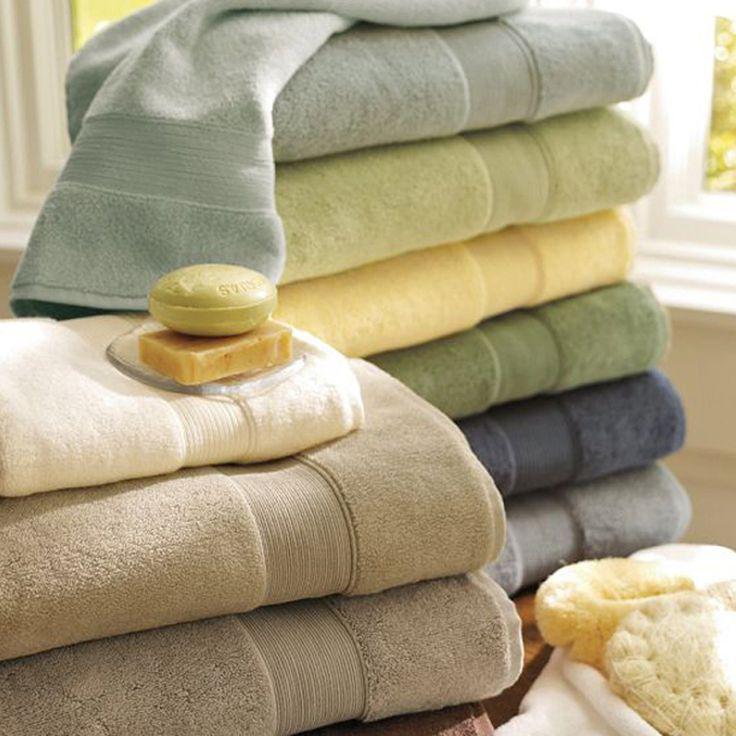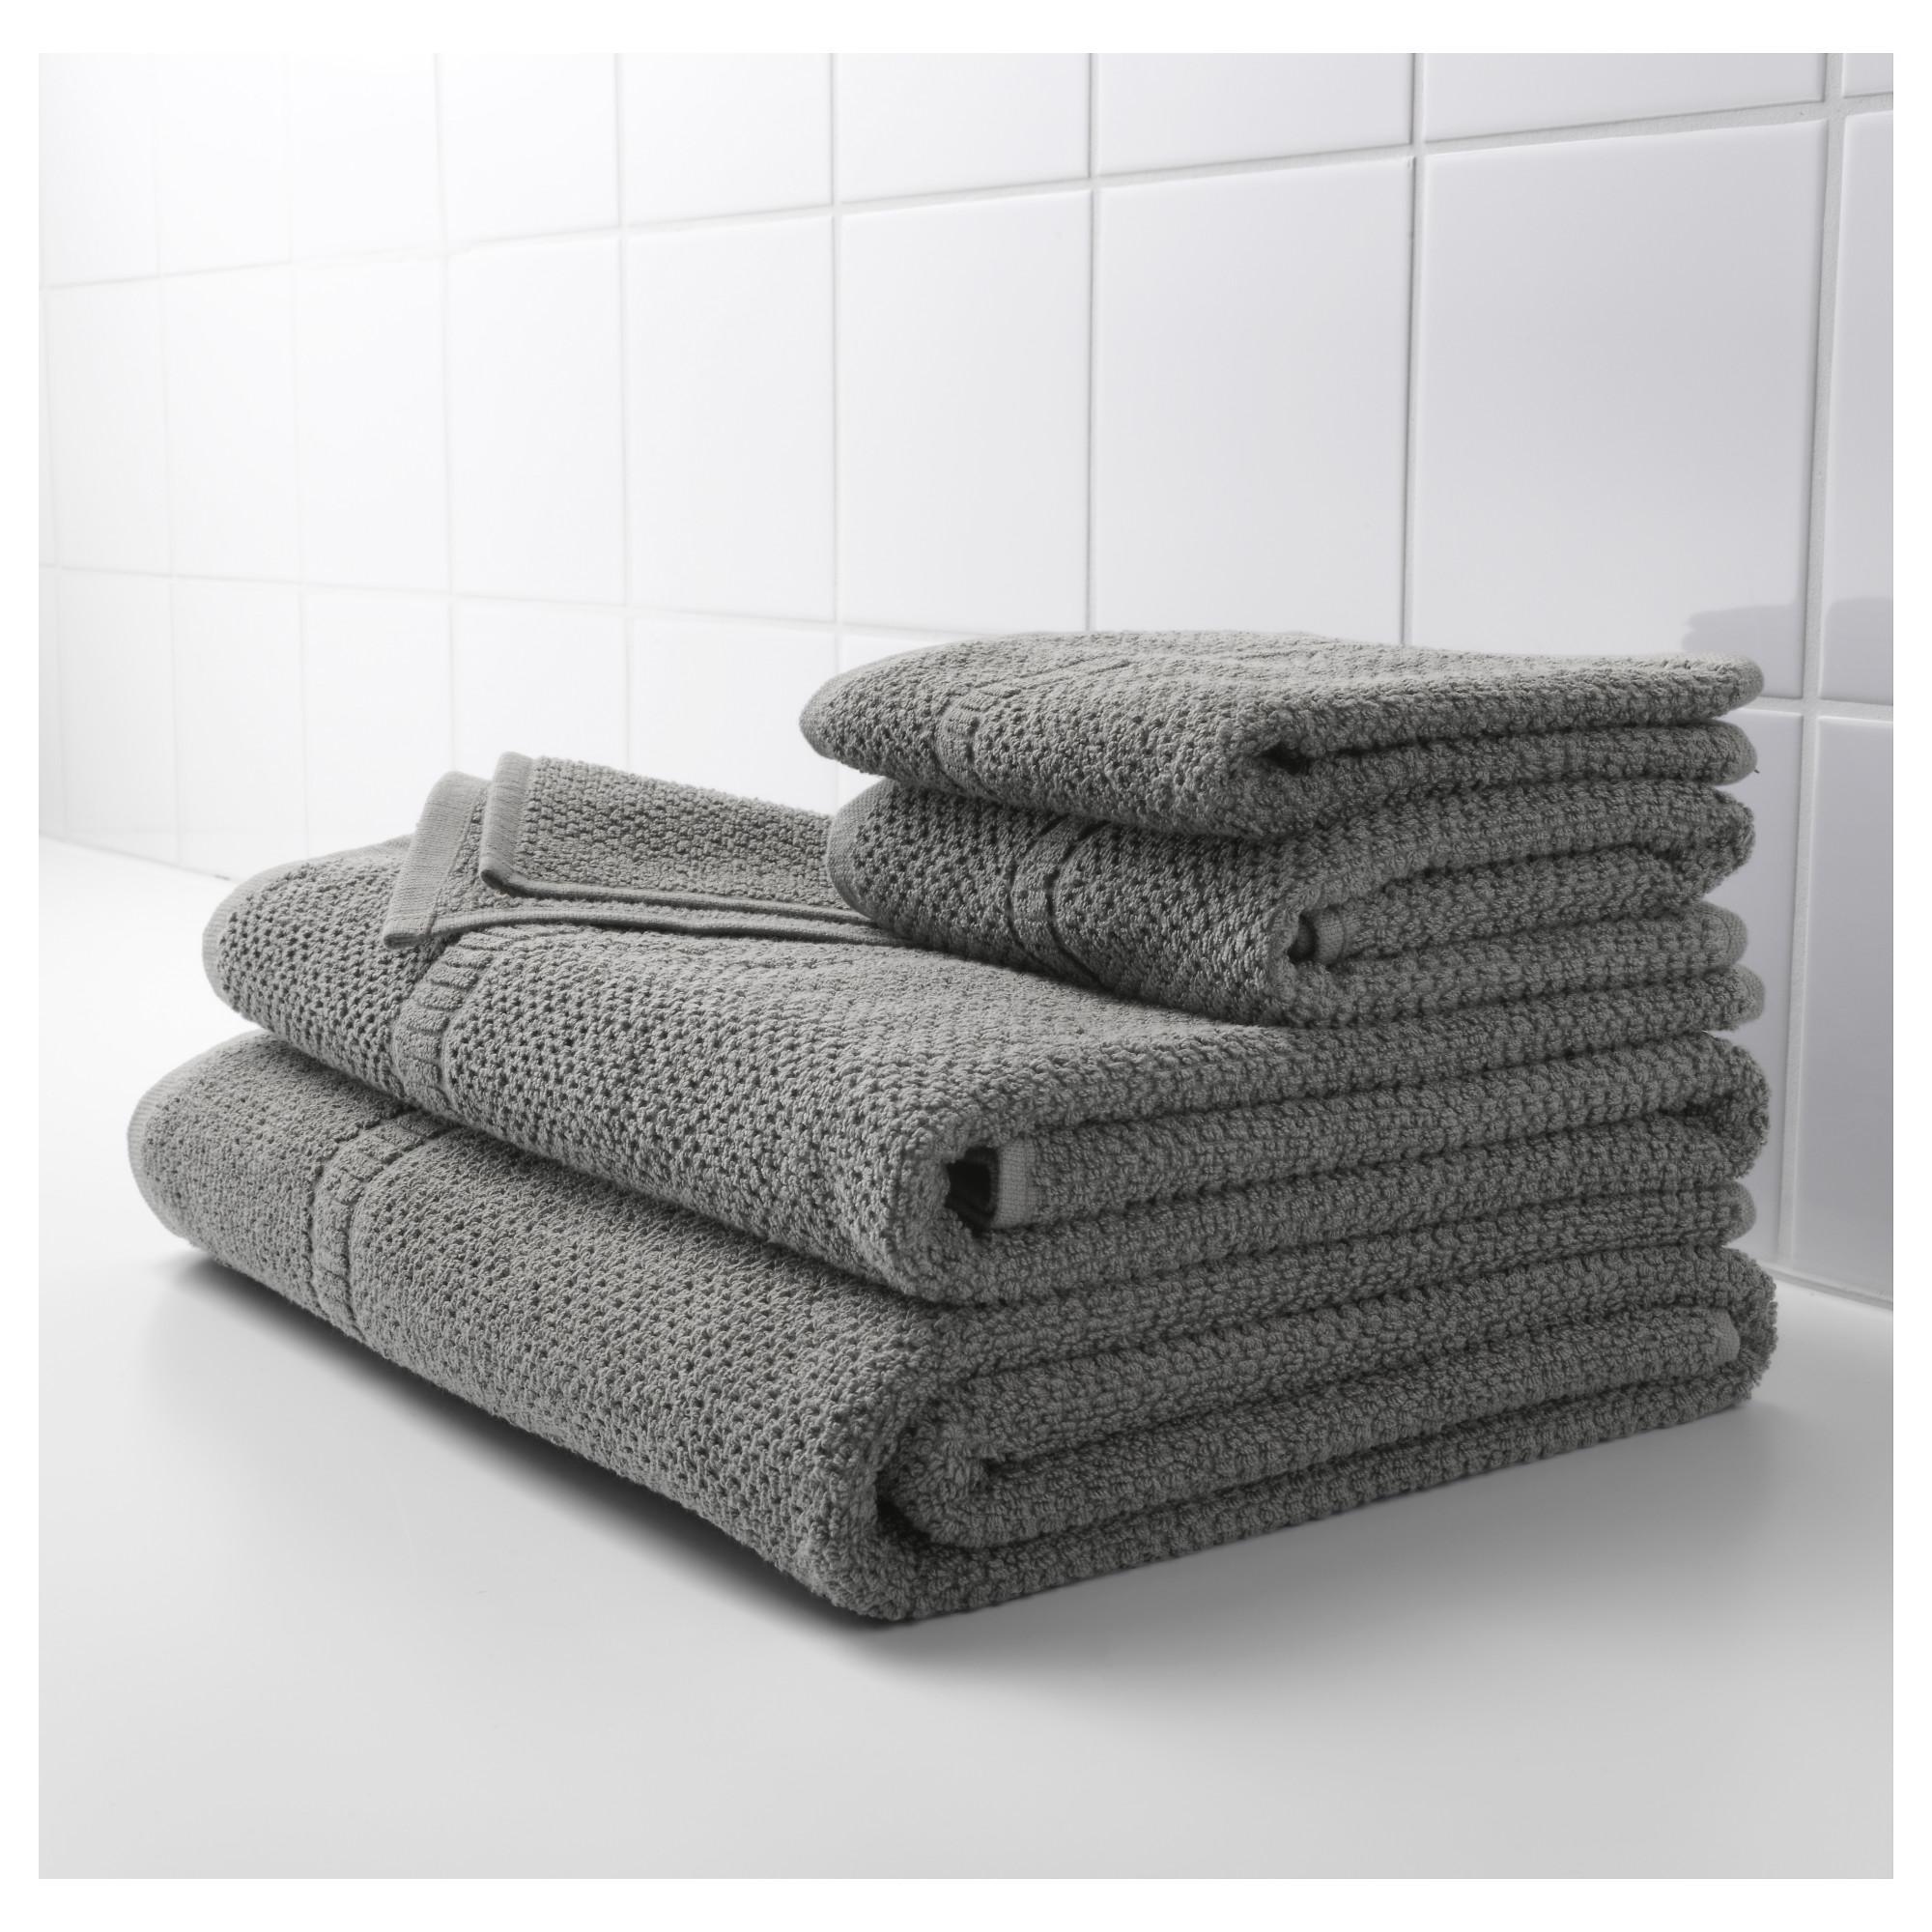The first image is the image on the left, the second image is the image on the right. Considering the images on both sides, is "The left image shows a stack of four white folded towels, and the right image shows a stack of at least 8 folded towels of different solid colors." valid? Answer yes or no. No. The first image is the image on the left, the second image is the image on the right. For the images displayed, is the sentence "There are multiple colors of towels in the right image." factually correct? Answer yes or no. No. 